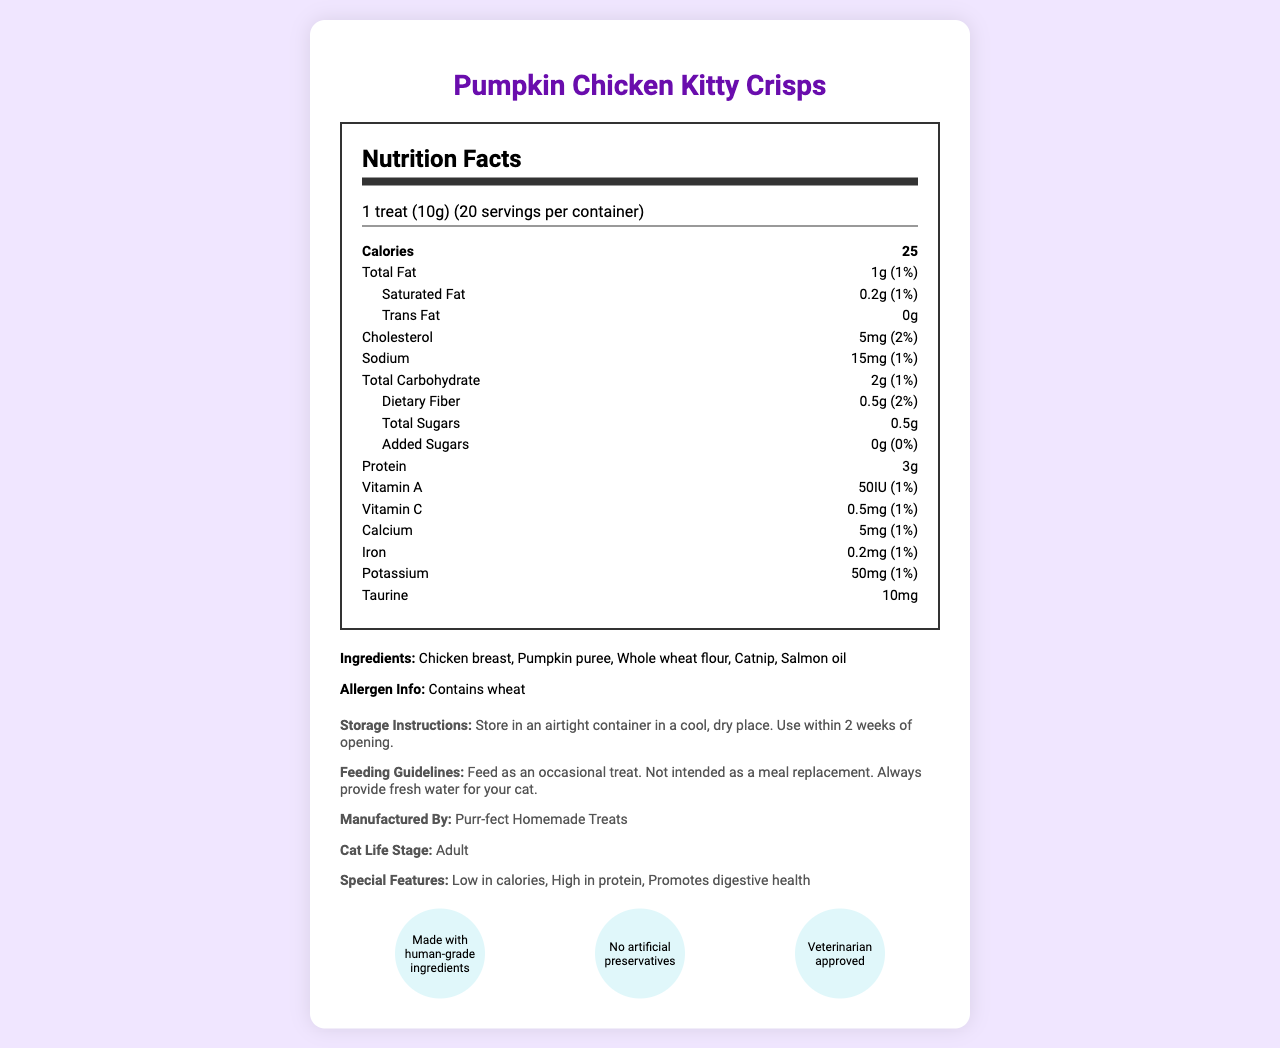what is the serving size? The serving size is stated as "1 treat (10g)" in the document.
Answer: 1 treat (10g) how many servings are in one container? The document mentions there are 20 servings per container.
Answer: 20 how many calories are there per serving? The document indicates that there are 25 calories per serving.
Answer: 25 calories what is the total fat content per serving? The total fat content is listed as "1g (1%)" per serving.
Answer: 1g (1%) what is the protein content per treat? The protein content per treat is mentioned as 3g.
Answer: 3g how much taurine is in each treat? The document states that there is 10mg of taurine per treat.
Answer: 10mg which ingredient is a potential allergen? A. Chicken breast B. Whole wheat flour C. Pumpkin puree D. Catnip The allergen info section specifies that the product contains wheat, which is found in whole wheat flour.
Answer: B how much dietary fiber is present per serving? The document reveals that there are 0.5g of dietary fiber per serving.
Answer: 0.5g (2%) what should you always provide for your cat when feeding these treats? The feeding guidelines specify always providing fresh water for your cat.
Answer: Fresh water who manufactures these treats? The manufacturer is listed as "Purr-fect Homemade Treats" in the document.
Answer: Purr-fect Homemade Treats are these treats suitable for kittens? The document states that these treats are for the "Adult" cat life stage.
Answer: No which feature is not listed for the treats? A. Low in calories B. High in protein C. Promotes dental health D. Promotes digestive health The features "Low in calories", "High in protein", and "Promotes digestive health" are mentioned, but not "Promotes dental health".
Answer: C are there any added sugars in these treats? The document explicitly states that there are 0g of added sugars (0% daily value).
Answer: No is the treat high in calories? Each treat has only 25 calories, which is relatively low.
Answer: No what certifications does this product have? The certifications listed are "Made with human-grade ingredients", "No artificial preservatives", and "Veterinarian approved".
Answer: Made with human-grade ingredients, No artificial preservatives, Veterinarian approved what is the main purpose of this document? The document includes nutrition facts, ingredients, allergen information, feeding guidelines, storage instructions, special features, and certifications for the Pumpkin Chicken Kitty Crisps.
Answer: To provide detailed nutritional information and other relevant details about the Pumpkin Chicken Kitty Crisps homemade cat treats. how much calcium is in each treat? The calcium content per treat is mentioned as 5mg with a daily value of 1%.
Answer: 5mg (1%) what is the flavor of these cat treats? The document does not explicitly mention the flavor, although it does list the main ingredients like chicken and pumpkin.
Answer: Cannot be determined what type of ingredient is catnip considered? A. Flavor enhancer B. Preservative C. Binding agent D. Natural ingredient Catnip is typically used as a natural ingredient in various cat products.
Answer: D what storage instructions are given for these treats? The document specifies storing in an airtight container, in a cool, dry place, and using within 2 weeks of opening.
Answer: Store in an airtight container in a cool, dry place. Use within 2 weeks of opening. how much vitamin A do these treats provide? The vitamin A content per treat is listed as 50IU with a daily value of 1%.
Answer: 50IU (1%) 